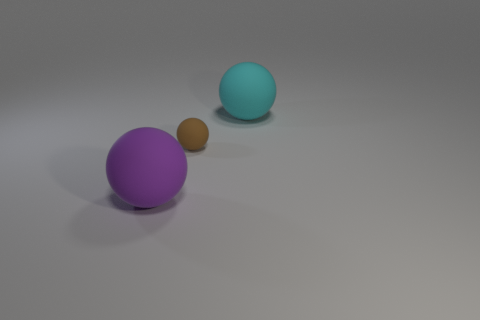What is the material of the purple thing that is the same shape as the tiny brown thing?
Give a very brief answer. Rubber. What color is the tiny matte object?
Offer a terse response. Brown. What number of metallic things are cyan blocks or large purple objects?
Ensure brevity in your answer.  0. There is a large sphere left of the big object that is behind the purple object; are there any small rubber things that are to the right of it?
Give a very brief answer. Yes. There is a brown sphere that is the same material as the big cyan sphere; what size is it?
Your answer should be compact. Small. Are there any large purple balls in front of the large cyan object?
Your answer should be very brief. Yes. Is there a cyan matte object on the left side of the big thing that is to the left of the cyan thing?
Keep it short and to the point. No. There is a rubber object that is in front of the tiny brown matte thing; is its size the same as the thing that is behind the small brown sphere?
Provide a short and direct response. Yes. What number of large things are either matte things or cyan things?
Provide a succinct answer. 2. There is a large thing that is to the left of the large object to the right of the big purple object; what is its material?
Offer a very short reply. Rubber. 